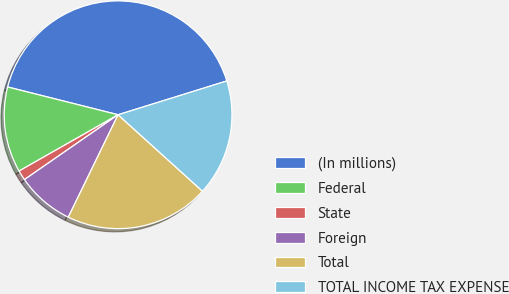<chart> <loc_0><loc_0><loc_500><loc_500><pie_chart><fcel>(In millions)<fcel>Federal<fcel>State<fcel>Foreign<fcel>Total<fcel>TOTAL INCOME TAX EXPENSE<nl><fcel>41.28%<fcel>12.15%<fcel>1.41%<fcel>8.16%<fcel>20.49%<fcel>16.51%<nl></chart> 